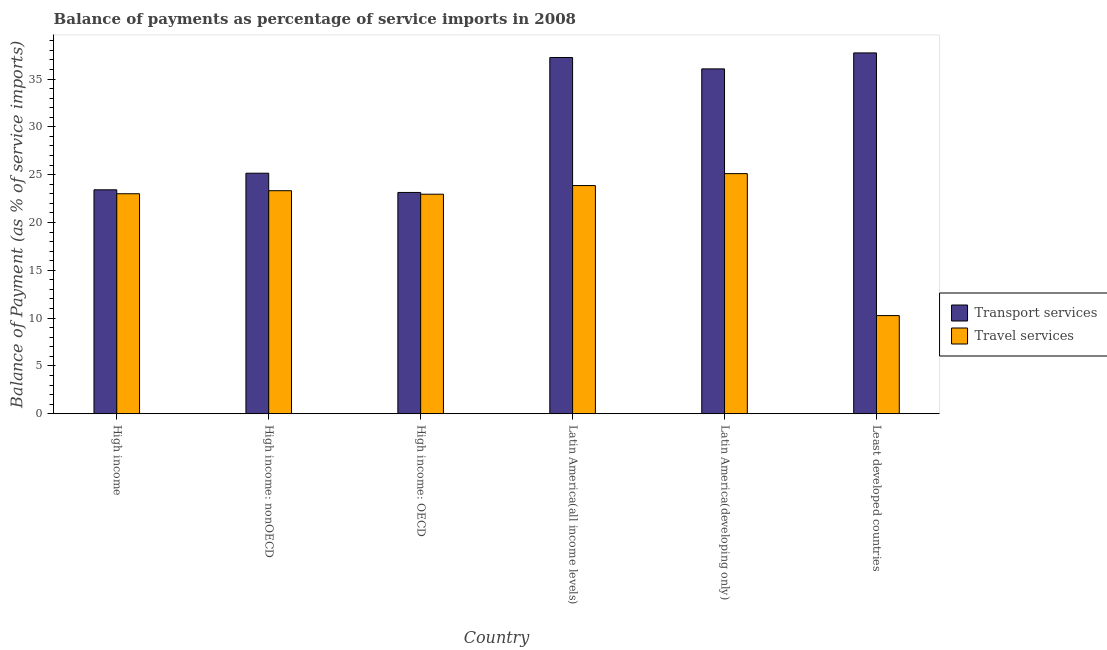How many groups of bars are there?
Give a very brief answer. 6. Are the number of bars per tick equal to the number of legend labels?
Offer a terse response. Yes. Are the number of bars on each tick of the X-axis equal?
Keep it short and to the point. Yes. What is the label of the 4th group of bars from the left?
Make the answer very short. Latin America(all income levels). What is the balance of payments of travel services in High income: nonOECD?
Provide a short and direct response. 23.32. Across all countries, what is the maximum balance of payments of travel services?
Your response must be concise. 25.11. Across all countries, what is the minimum balance of payments of transport services?
Provide a succinct answer. 23.14. In which country was the balance of payments of transport services maximum?
Keep it short and to the point. Least developed countries. In which country was the balance of payments of transport services minimum?
Offer a very short reply. High income: OECD. What is the total balance of payments of transport services in the graph?
Your answer should be compact. 182.76. What is the difference between the balance of payments of transport services in Latin America(all income levels) and that in Least developed countries?
Offer a very short reply. -0.48. What is the difference between the balance of payments of travel services in Latin America(developing only) and the balance of payments of transport services in High income?
Your response must be concise. 1.69. What is the average balance of payments of transport services per country?
Keep it short and to the point. 30.46. What is the difference between the balance of payments of transport services and balance of payments of travel services in High income?
Your answer should be compact. 0.41. In how many countries, is the balance of payments of travel services greater than 15 %?
Offer a terse response. 5. What is the ratio of the balance of payments of transport services in Latin America(developing only) to that in Least developed countries?
Make the answer very short. 0.96. Is the difference between the balance of payments of travel services in High income and Latin America(all income levels) greater than the difference between the balance of payments of transport services in High income and Latin America(all income levels)?
Make the answer very short. Yes. What is the difference between the highest and the second highest balance of payments of transport services?
Your answer should be compact. 0.48. What is the difference between the highest and the lowest balance of payments of travel services?
Your answer should be very brief. 14.84. What does the 2nd bar from the left in Least developed countries represents?
Give a very brief answer. Travel services. What does the 1st bar from the right in High income: OECD represents?
Provide a short and direct response. Travel services. How many bars are there?
Your answer should be very brief. 12. Are all the bars in the graph horizontal?
Provide a short and direct response. No. How many countries are there in the graph?
Your answer should be very brief. 6. What is the difference between two consecutive major ticks on the Y-axis?
Offer a terse response. 5. Are the values on the major ticks of Y-axis written in scientific E-notation?
Your answer should be compact. No. Does the graph contain grids?
Your answer should be compact. No. How are the legend labels stacked?
Give a very brief answer. Vertical. What is the title of the graph?
Give a very brief answer. Balance of payments as percentage of service imports in 2008. Does "Constant 2005 US$" appear as one of the legend labels in the graph?
Give a very brief answer. No. What is the label or title of the X-axis?
Your answer should be compact. Country. What is the label or title of the Y-axis?
Make the answer very short. Balance of Payment (as % of service imports). What is the Balance of Payment (as % of service imports) of Transport services in High income?
Keep it short and to the point. 23.42. What is the Balance of Payment (as % of service imports) in Travel services in High income?
Offer a very short reply. 23.01. What is the Balance of Payment (as % of service imports) of Transport services in High income: nonOECD?
Your answer should be very brief. 25.15. What is the Balance of Payment (as % of service imports) in Travel services in High income: nonOECD?
Offer a very short reply. 23.32. What is the Balance of Payment (as % of service imports) in Transport services in High income: OECD?
Make the answer very short. 23.14. What is the Balance of Payment (as % of service imports) of Travel services in High income: OECD?
Offer a very short reply. 22.96. What is the Balance of Payment (as % of service imports) of Transport services in Latin America(all income levels)?
Give a very brief answer. 37.25. What is the Balance of Payment (as % of service imports) of Travel services in Latin America(all income levels)?
Keep it short and to the point. 23.86. What is the Balance of Payment (as % of service imports) in Transport services in Latin America(developing only)?
Give a very brief answer. 36.06. What is the Balance of Payment (as % of service imports) of Travel services in Latin America(developing only)?
Ensure brevity in your answer.  25.11. What is the Balance of Payment (as % of service imports) in Transport services in Least developed countries?
Offer a very short reply. 37.73. What is the Balance of Payment (as % of service imports) of Travel services in Least developed countries?
Provide a succinct answer. 10.26. Across all countries, what is the maximum Balance of Payment (as % of service imports) in Transport services?
Your answer should be compact. 37.73. Across all countries, what is the maximum Balance of Payment (as % of service imports) in Travel services?
Offer a very short reply. 25.11. Across all countries, what is the minimum Balance of Payment (as % of service imports) of Transport services?
Provide a short and direct response. 23.14. Across all countries, what is the minimum Balance of Payment (as % of service imports) in Travel services?
Ensure brevity in your answer.  10.26. What is the total Balance of Payment (as % of service imports) of Transport services in the graph?
Ensure brevity in your answer.  182.76. What is the total Balance of Payment (as % of service imports) in Travel services in the graph?
Provide a short and direct response. 128.52. What is the difference between the Balance of Payment (as % of service imports) in Transport services in High income and that in High income: nonOECD?
Provide a short and direct response. -1.74. What is the difference between the Balance of Payment (as % of service imports) in Travel services in High income and that in High income: nonOECD?
Provide a succinct answer. -0.32. What is the difference between the Balance of Payment (as % of service imports) of Transport services in High income and that in High income: OECD?
Your response must be concise. 0.28. What is the difference between the Balance of Payment (as % of service imports) in Travel services in High income and that in High income: OECD?
Offer a terse response. 0.05. What is the difference between the Balance of Payment (as % of service imports) of Transport services in High income and that in Latin America(all income levels)?
Offer a very short reply. -13.84. What is the difference between the Balance of Payment (as % of service imports) of Travel services in High income and that in Latin America(all income levels)?
Ensure brevity in your answer.  -0.86. What is the difference between the Balance of Payment (as % of service imports) of Transport services in High income and that in Latin America(developing only)?
Provide a short and direct response. -12.65. What is the difference between the Balance of Payment (as % of service imports) in Travel services in High income and that in Latin America(developing only)?
Your response must be concise. -2.1. What is the difference between the Balance of Payment (as % of service imports) of Transport services in High income and that in Least developed countries?
Provide a short and direct response. -14.31. What is the difference between the Balance of Payment (as % of service imports) of Travel services in High income and that in Least developed countries?
Keep it short and to the point. 12.74. What is the difference between the Balance of Payment (as % of service imports) of Transport services in High income: nonOECD and that in High income: OECD?
Provide a short and direct response. 2.01. What is the difference between the Balance of Payment (as % of service imports) of Travel services in High income: nonOECD and that in High income: OECD?
Give a very brief answer. 0.37. What is the difference between the Balance of Payment (as % of service imports) of Transport services in High income: nonOECD and that in Latin America(all income levels)?
Ensure brevity in your answer.  -12.1. What is the difference between the Balance of Payment (as % of service imports) of Travel services in High income: nonOECD and that in Latin America(all income levels)?
Provide a short and direct response. -0.54. What is the difference between the Balance of Payment (as % of service imports) of Transport services in High income: nonOECD and that in Latin America(developing only)?
Provide a short and direct response. -10.91. What is the difference between the Balance of Payment (as % of service imports) in Travel services in High income: nonOECD and that in Latin America(developing only)?
Your response must be concise. -1.79. What is the difference between the Balance of Payment (as % of service imports) of Transport services in High income: nonOECD and that in Least developed countries?
Provide a short and direct response. -12.58. What is the difference between the Balance of Payment (as % of service imports) of Travel services in High income: nonOECD and that in Least developed countries?
Provide a short and direct response. 13.06. What is the difference between the Balance of Payment (as % of service imports) in Transport services in High income: OECD and that in Latin America(all income levels)?
Provide a succinct answer. -14.11. What is the difference between the Balance of Payment (as % of service imports) of Travel services in High income: OECD and that in Latin America(all income levels)?
Keep it short and to the point. -0.91. What is the difference between the Balance of Payment (as % of service imports) of Transport services in High income: OECD and that in Latin America(developing only)?
Your response must be concise. -12.92. What is the difference between the Balance of Payment (as % of service imports) in Travel services in High income: OECD and that in Latin America(developing only)?
Keep it short and to the point. -2.15. What is the difference between the Balance of Payment (as % of service imports) in Transport services in High income: OECD and that in Least developed countries?
Keep it short and to the point. -14.59. What is the difference between the Balance of Payment (as % of service imports) in Travel services in High income: OECD and that in Least developed countries?
Your answer should be compact. 12.69. What is the difference between the Balance of Payment (as % of service imports) of Transport services in Latin America(all income levels) and that in Latin America(developing only)?
Provide a succinct answer. 1.19. What is the difference between the Balance of Payment (as % of service imports) of Travel services in Latin America(all income levels) and that in Latin America(developing only)?
Provide a short and direct response. -1.25. What is the difference between the Balance of Payment (as % of service imports) of Transport services in Latin America(all income levels) and that in Least developed countries?
Ensure brevity in your answer.  -0.48. What is the difference between the Balance of Payment (as % of service imports) in Travel services in Latin America(all income levels) and that in Least developed countries?
Your answer should be compact. 13.6. What is the difference between the Balance of Payment (as % of service imports) of Transport services in Latin America(developing only) and that in Least developed countries?
Your response must be concise. -1.67. What is the difference between the Balance of Payment (as % of service imports) of Travel services in Latin America(developing only) and that in Least developed countries?
Offer a terse response. 14.84. What is the difference between the Balance of Payment (as % of service imports) of Transport services in High income and the Balance of Payment (as % of service imports) of Travel services in High income: nonOECD?
Offer a very short reply. 0.1. What is the difference between the Balance of Payment (as % of service imports) of Transport services in High income and the Balance of Payment (as % of service imports) of Travel services in High income: OECD?
Offer a very short reply. 0.46. What is the difference between the Balance of Payment (as % of service imports) of Transport services in High income and the Balance of Payment (as % of service imports) of Travel services in Latin America(all income levels)?
Make the answer very short. -0.44. What is the difference between the Balance of Payment (as % of service imports) in Transport services in High income and the Balance of Payment (as % of service imports) in Travel services in Latin America(developing only)?
Your answer should be compact. -1.69. What is the difference between the Balance of Payment (as % of service imports) of Transport services in High income and the Balance of Payment (as % of service imports) of Travel services in Least developed countries?
Provide a succinct answer. 13.15. What is the difference between the Balance of Payment (as % of service imports) of Transport services in High income: nonOECD and the Balance of Payment (as % of service imports) of Travel services in High income: OECD?
Ensure brevity in your answer.  2.2. What is the difference between the Balance of Payment (as % of service imports) of Transport services in High income: nonOECD and the Balance of Payment (as % of service imports) of Travel services in Latin America(all income levels)?
Give a very brief answer. 1.29. What is the difference between the Balance of Payment (as % of service imports) of Transport services in High income: nonOECD and the Balance of Payment (as % of service imports) of Travel services in Latin America(developing only)?
Keep it short and to the point. 0.04. What is the difference between the Balance of Payment (as % of service imports) in Transport services in High income: nonOECD and the Balance of Payment (as % of service imports) in Travel services in Least developed countries?
Ensure brevity in your answer.  14.89. What is the difference between the Balance of Payment (as % of service imports) of Transport services in High income: OECD and the Balance of Payment (as % of service imports) of Travel services in Latin America(all income levels)?
Your answer should be very brief. -0.72. What is the difference between the Balance of Payment (as % of service imports) of Transport services in High income: OECD and the Balance of Payment (as % of service imports) of Travel services in Latin America(developing only)?
Keep it short and to the point. -1.97. What is the difference between the Balance of Payment (as % of service imports) of Transport services in High income: OECD and the Balance of Payment (as % of service imports) of Travel services in Least developed countries?
Your answer should be compact. 12.88. What is the difference between the Balance of Payment (as % of service imports) in Transport services in Latin America(all income levels) and the Balance of Payment (as % of service imports) in Travel services in Latin America(developing only)?
Offer a terse response. 12.15. What is the difference between the Balance of Payment (as % of service imports) of Transport services in Latin America(all income levels) and the Balance of Payment (as % of service imports) of Travel services in Least developed countries?
Your response must be concise. 26.99. What is the difference between the Balance of Payment (as % of service imports) of Transport services in Latin America(developing only) and the Balance of Payment (as % of service imports) of Travel services in Least developed countries?
Your answer should be compact. 25.8. What is the average Balance of Payment (as % of service imports) in Transport services per country?
Provide a succinct answer. 30.46. What is the average Balance of Payment (as % of service imports) in Travel services per country?
Keep it short and to the point. 21.42. What is the difference between the Balance of Payment (as % of service imports) of Transport services and Balance of Payment (as % of service imports) of Travel services in High income?
Offer a terse response. 0.41. What is the difference between the Balance of Payment (as % of service imports) in Transport services and Balance of Payment (as % of service imports) in Travel services in High income: nonOECD?
Provide a succinct answer. 1.83. What is the difference between the Balance of Payment (as % of service imports) in Transport services and Balance of Payment (as % of service imports) in Travel services in High income: OECD?
Your response must be concise. 0.19. What is the difference between the Balance of Payment (as % of service imports) in Transport services and Balance of Payment (as % of service imports) in Travel services in Latin America(all income levels)?
Your response must be concise. 13.39. What is the difference between the Balance of Payment (as % of service imports) of Transport services and Balance of Payment (as % of service imports) of Travel services in Latin America(developing only)?
Offer a very short reply. 10.96. What is the difference between the Balance of Payment (as % of service imports) of Transport services and Balance of Payment (as % of service imports) of Travel services in Least developed countries?
Provide a succinct answer. 27.47. What is the ratio of the Balance of Payment (as % of service imports) of Travel services in High income to that in High income: nonOECD?
Give a very brief answer. 0.99. What is the ratio of the Balance of Payment (as % of service imports) in Transport services in High income to that in High income: OECD?
Offer a terse response. 1.01. What is the ratio of the Balance of Payment (as % of service imports) in Transport services in High income to that in Latin America(all income levels)?
Give a very brief answer. 0.63. What is the ratio of the Balance of Payment (as % of service imports) in Travel services in High income to that in Latin America(all income levels)?
Your response must be concise. 0.96. What is the ratio of the Balance of Payment (as % of service imports) of Transport services in High income to that in Latin America(developing only)?
Offer a terse response. 0.65. What is the ratio of the Balance of Payment (as % of service imports) in Travel services in High income to that in Latin America(developing only)?
Offer a very short reply. 0.92. What is the ratio of the Balance of Payment (as % of service imports) in Transport services in High income to that in Least developed countries?
Offer a terse response. 0.62. What is the ratio of the Balance of Payment (as % of service imports) of Travel services in High income to that in Least developed countries?
Give a very brief answer. 2.24. What is the ratio of the Balance of Payment (as % of service imports) of Transport services in High income: nonOECD to that in High income: OECD?
Your answer should be very brief. 1.09. What is the ratio of the Balance of Payment (as % of service imports) of Travel services in High income: nonOECD to that in High income: OECD?
Your response must be concise. 1.02. What is the ratio of the Balance of Payment (as % of service imports) of Transport services in High income: nonOECD to that in Latin America(all income levels)?
Give a very brief answer. 0.68. What is the ratio of the Balance of Payment (as % of service imports) in Travel services in High income: nonOECD to that in Latin America(all income levels)?
Keep it short and to the point. 0.98. What is the ratio of the Balance of Payment (as % of service imports) of Transport services in High income: nonOECD to that in Latin America(developing only)?
Your response must be concise. 0.7. What is the ratio of the Balance of Payment (as % of service imports) of Travel services in High income: nonOECD to that in Latin America(developing only)?
Give a very brief answer. 0.93. What is the ratio of the Balance of Payment (as % of service imports) of Transport services in High income: nonOECD to that in Least developed countries?
Your answer should be very brief. 0.67. What is the ratio of the Balance of Payment (as % of service imports) in Travel services in High income: nonOECD to that in Least developed countries?
Provide a succinct answer. 2.27. What is the ratio of the Balance of Payment (as % of service imports) of Transport services in High income: OECD to that in Latin America(all income levels)?
Make the answer very short. 0.62. What is the ratio of the Balance of Payment (as % of service imports) of Transport services in High income: OECD to that in Latin America(developing only)?
Your answer should be compact. 0.64. What is the ratio of the Balance of Payment (as % of service imports) in Travel services in High income: OECD to that in Latin America(developing only)?
Ensure brevity in your answer.  0.91. What is the ratio of the Balance of Payment (as % of service imports) in Transport services in High income: OECD to that in Least developed countries?
Your answer should be compact. 0.61. What is the ratio of the Balance of Payment (as % of service imports) of Travel services in High income: OECD to that in Least developed countries?
Offer a very short reply. 2.24. What is the ratio of the Balance of Payment (as % of service imports) of Transport services in Latin America(all income levels) to that in Latin America(developing only)?
Provide a short and direct response. 1.03. What is the ratio of the Balance of Payment (as % of service imports) of Travel services in Latin America(all income levels) to that in Latin America(developing only)?
Offer a very short reply. 0.95. What is the ratio of the Balance of Payment (as % of service imports) of Transport services in Latin America(all income levels) to that in Least developed countries?
Your response must be concise. 0.99. What is the ratio of the Balance of Payment (as % of service imports) of Travel services in Latin America(all income levels) to that in Least developed countries?
Make the answer very short. 2.32. What is the ratio of the Balance of Payment (as % of service imports) of Transport services in Latin America(developing only) to that in Least developed countries?
Offer a very short reply. 0.96. What is the ratio of the Balance of Payment (as % of service imports) of Travel services in Latin America(developing only) to that in Least developed countries?
Make the answer very short. 2.45. What is the difference between the highest and the second highest Balance of Payment (as % of service imports) of Transport services?
Provide a succinct answer. 0.48. What is the difference between the highest and the second highest Balance of Payment (as % of service imports) in Travel services?
Give a very brief answer. 1.25. What is the difference between the highest and the lowest Balance of Payment (as % of service imports) of Transport services?
Make the answer very short. 14.59. What is the difference between the highest and the lowest Balance of Payment (as % of service imports) of Travel services?
Your answer should be compact. 14.84. 